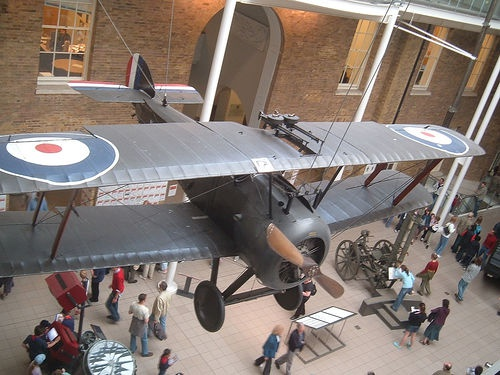Describe the objects in this image and their specific colors. I can see airplane in black, gray, darkgray, and lightgray tones, people in black, gray, darkgray, and maroon tones, people in black, gray, darkgray, lightgray, and blue tones, people in black and gray tones, and people in black, blue, gray, and darkgray tones in this image. 